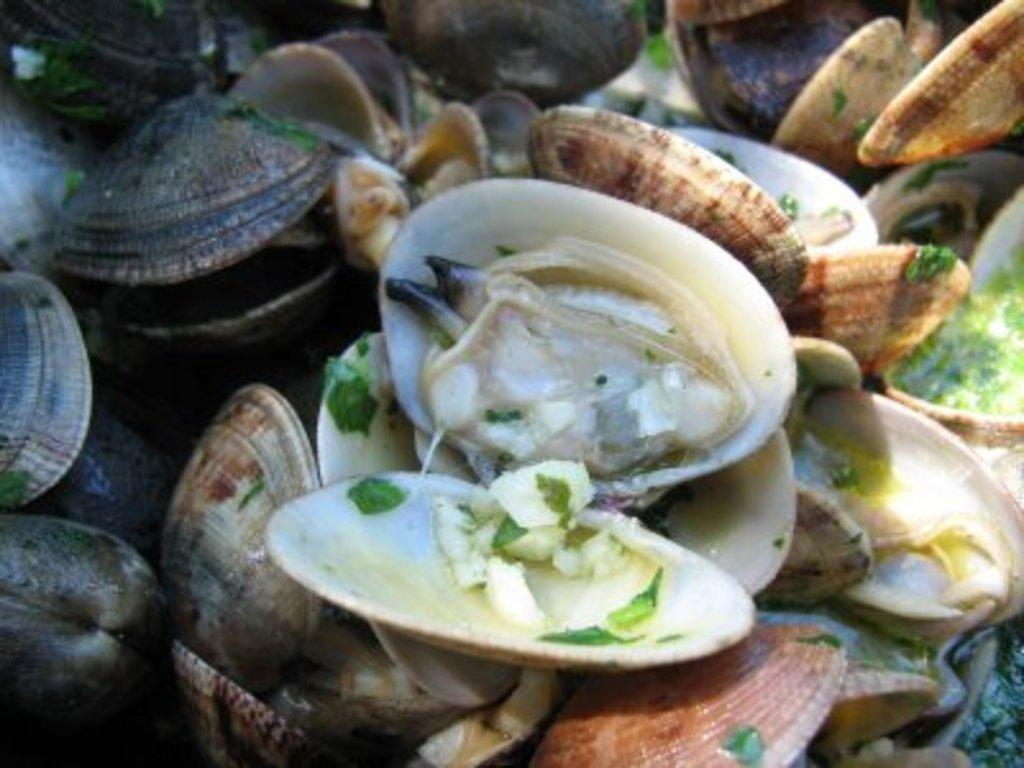What is the main subject of the image? The main subject of the image is a group of shells. Can you describe the shells in the image? The shells in the image are in different colors. How many ladybugs are crawling on the shells in the image? There are no ladybugs present in the image; it only features a group of shells in different colors. 